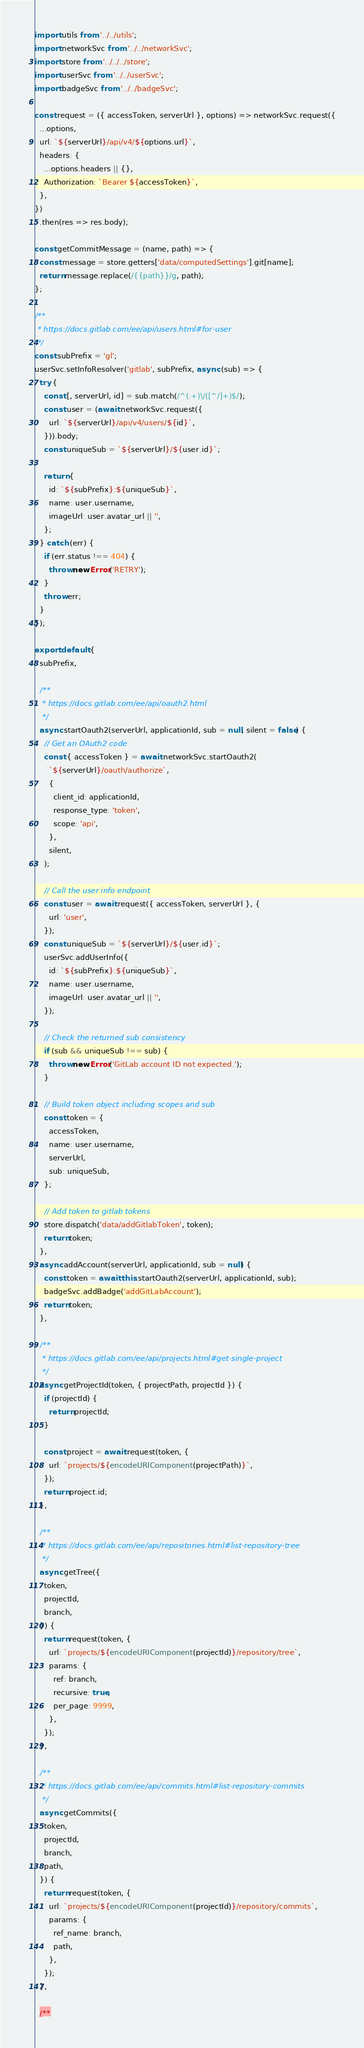<code> <loc_0><loc_0><loc_500><loc_500><_JavaScript_>import utils from '../../utils';
import networkSvc from '../../networkSvc';
import store from '../../../store';
import userSvc from '../../userSvc';
import badgeSvc from '../../badgeSvc';

const request = ({ accessToken, serverUrl }, options) => networkSvc.request({
  ...options,
  url: `${serverUrl}/api/v4/${options.url}`,
  headers: {
    ...options.headers || {},
    Authorization: `Bearer ${accessToken}`,
  },
})
  .then(res => res.body);

const getCommitMessage = (name, path) => {
  const message = store.getters['data/computedSettings'].git[name];
  return message.replace(/{{path}}/g, path);
};

/**
 * https://docs.gitlab.com/ee/api/users.html#for-user
 */
const subPrefix = 'gl';
userSvc.setInfoResolver('gitlab', subPrefix, async (sub) => {
  try {
    const [, serverUrl, id] = sub.match(/^(.+)\/([^/]+)$/);
    const user = (await networkSvc.request({
      url: `${serverUrl}/api/v4/users/${id}`,
    })).body;
    const uniqueSub = `${serverUrl}/${user.id}`;

    return {
      id: `${subPrefix}:${uniqueSub}`,
      name: user.username,
      imageUrl: user.avatar_url || '',
    };
  } catch (err) {
    if (err.status !== 404) {
      throw new Error('RETRY');
    }
    throw err;
  }
});

export default {
  subPrefix,

  /**
   * https://docs.gitlab.com/ee/api/oauth2.html
   */
  async startOauth2(serverUrl, applicationId, sub = null, silent = false) {
    // Get an OAuth2 code
    const { accessToken } = await networkSvc.startOauth2(
      `${serverUrl}/oauth/authorize`,
      {
        client_id: applicationId,
        response_type: 'token',
        scope: 'api',
      },
      silent,
    );

    // Call the user info endpoint
    const user = await request({ accessToken, serverUrl }, {
      url: 'user',
    });
    const uniqueSub = `${serverUrl}/${user.id}`;
    userSvc.addUserInfo({
      id: `${subPrefix}:${uniqueSub}`,
      name: user.username,
      imageUrl: user.avatar_url || '',
    });

    // Check the returned sub consistency
    if (sub && uniqueSub !== sub) {
      throw new Error('GitLab account ID not expected.');
    }

    // Build token object including scopes and sub
    const token = {
      accessToken,
      name: user.username,
      serverUrl,
      sub: uniqueSub,
    };

    // Add token to gitlab tokens
    store.dispatch('data/addGitlabToken', token);
    return token;
  },
  async addAccount(serverUrl, applicationId, sub = null) {
    const token = await this.startOauth2(serverUrl, applicationId, sub);
    badgeSvc.addBadge('addGitLabAccount');
    return token;
  },

  /**
   * https://docs.gitlab.com/ee/api/projects.html#get-single-project
   */
  async getProjectId(token, { projectPath, projectId }) {
    if (projectId) {
      return projectId;
    }

    const project = await request(token, {
      url: `projects/${encodeURIComponent(projectPath)}`,
    });
    return project.id;
  },

  /**
   * https://docs.gitlab.com/ee/api/repositories.html#list-repository-tree
   */
  async getTree({
    token,
    projectId,
    branch,
  }) {
    return request(token, {
      url: `projects/${encodeURIComponent(projectId)}/repository/tree`,
      params: {
        ref: branch,
        recursive: true,
        per_page: 9999,
      },
    });
  },

  /**
   * https://docs.gitlab.com/ee/api/commits.html#list-repository-commits
   */
  async getCommits({
    token,
    projectId,
    branch,
    path,
  }) {
    return request(token, {
      url: `projects/${encodeURIComponent(projectId)}/repository/commits`,
      params: {
        ref_name: branch,
        path,
      },
    });
  },

  /**</code> 